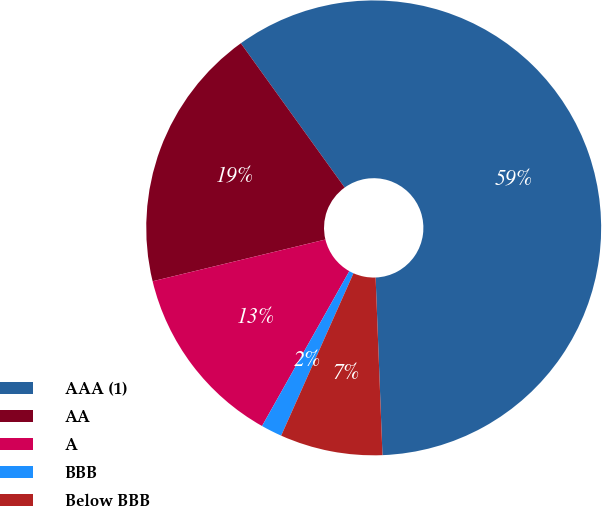Convert chart to OTSL. <chart><loc_0><loc_0><loc_500><loc_500><pie_chart><fcel>AAA (1)<fcel>AA<fcel>A<fcel>BBB<fcel>Below BBB<nl><fcel>59.31%<fcel>18.84%<fcel>13.06%<fcel>1.5%<fcel>7.28%<nl></chart> 